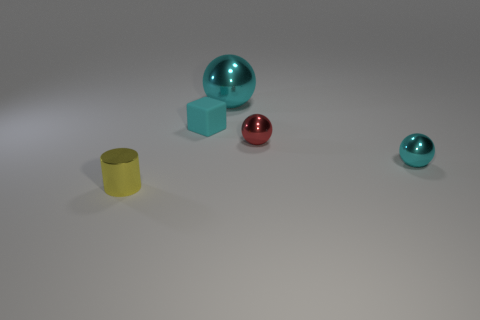Subtract all cyan spheres. How many spheres are left? 1 Add 3 balls. How many objects exist? 8 Subtract all small balls. How many balls are left? 1 Subtract all brown cylinders. How many cyan balls are left? 2 Add 3 small cyan objects. How many small cyan objects exist? 5 Subtract 0 gray cylinders. How many objects are left? 5 Subtract all balls. How many objects are left? 2 Subtract 1 blocks. How many blocks are left? 0 Subtract all yellow spheres. Subtract all blue cubes. How many spheres are left? 3 Subtract all red shiny objects. Subtract all cyan metallic balls. How many objects are left? 2 